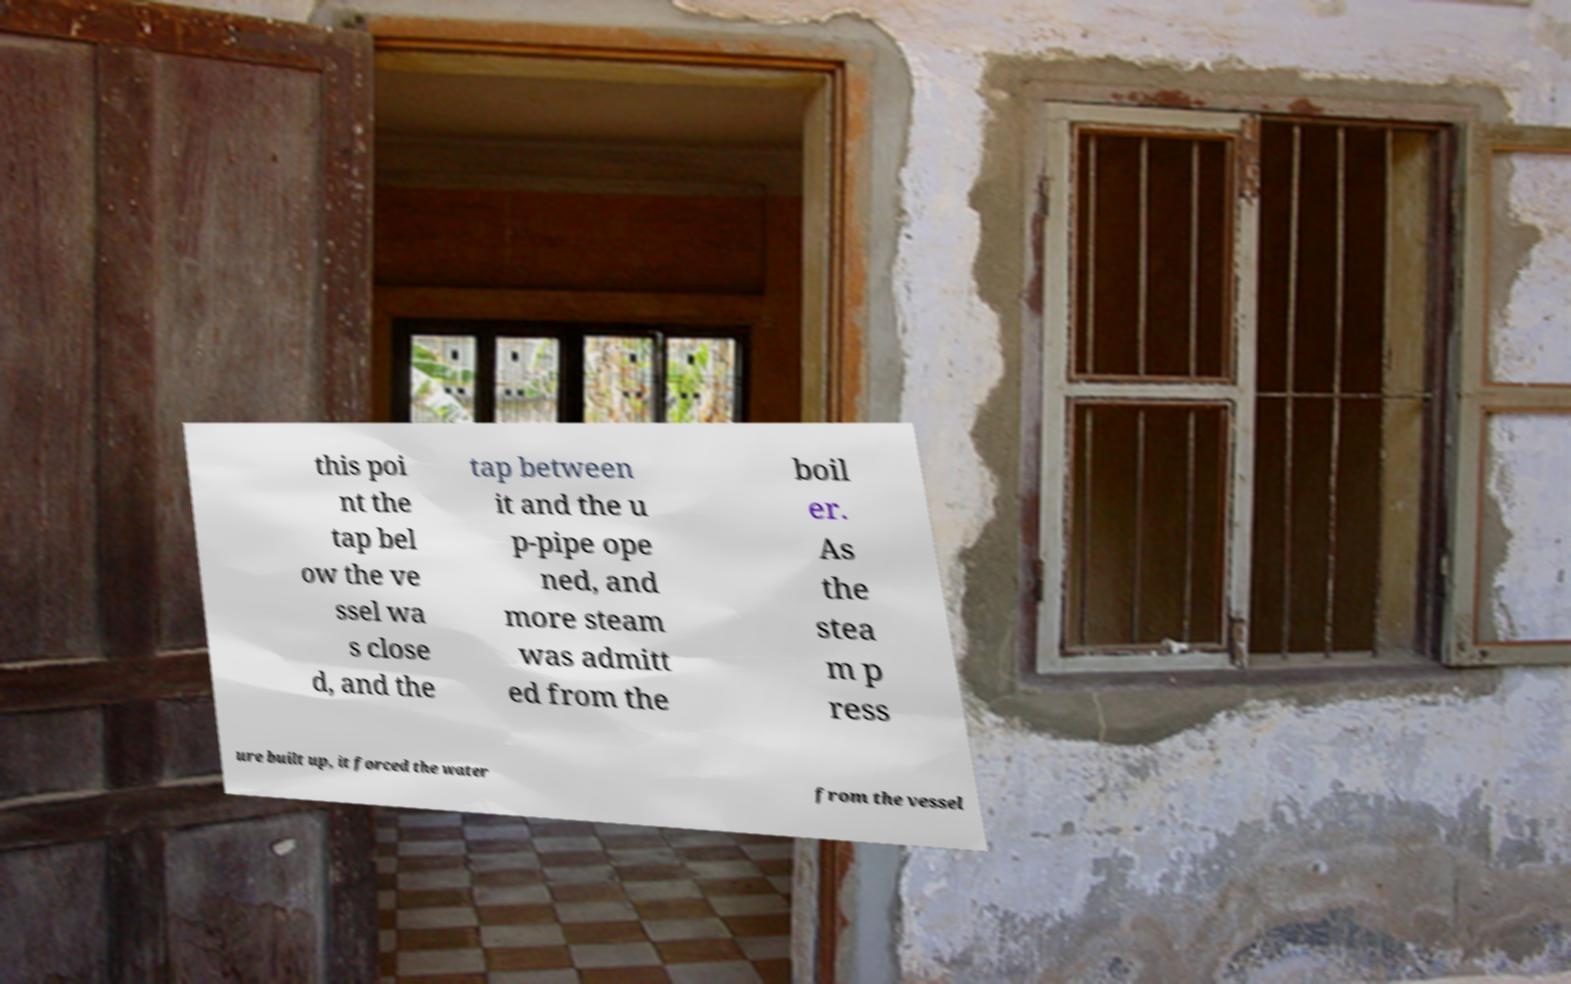Could you extract and type out the text from this image? this poi nt the tap bel ow the ve ssel wa s close d, and the tap between it and the u p-pipe ope ned, and more steam was admitt ed from the boil er. As the stea m p ress ure built up, it forced the water from the vessel 